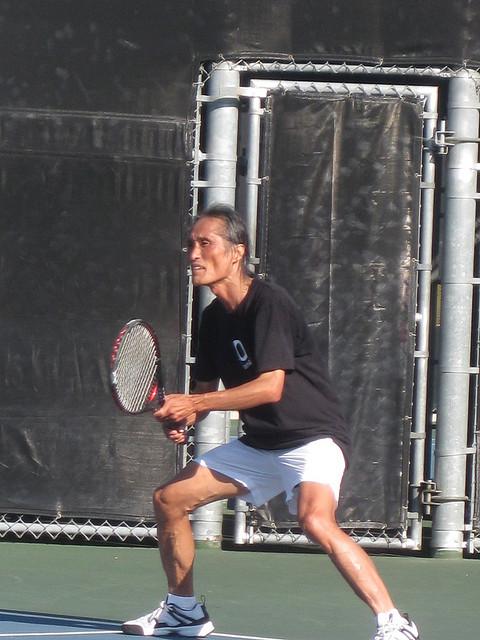Is the man wearing sandals?
Give a very brief answer. No. What color is his racket?
Be succinct. Black. Which hand is holding the handle of the tennis racket?
Keep it brief. Right. 